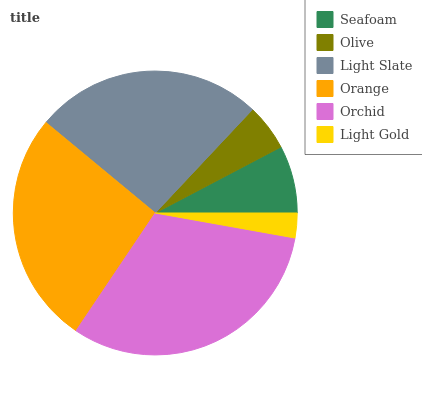Is Light Gold the minimum?
Answer yes or no. Yes. Is Orchid the maximum?
Answer yes or no. Yes. Is Olive the minimum?
Answer yes or no. No. Is Olive the maximum?
Answer yes or no. No. Is Seafoam greater than Olive?
Answer yes or no. Yes. Is Olive less than Seafoam?
Answer yes or no. Yes. Is Olive greater than Seafoam?
Answer yes or no. No. Is Seafoam less than Olive?
Answer yes or no. No. Is Light Slate the high median?
Answer yes or no. Yes. Is Seafoam the low median?
Answer yes or no. Yes. Is Orchid the high median?
Answer yes or no. No. Is Orange the low median?
Answer yes or no. No. 